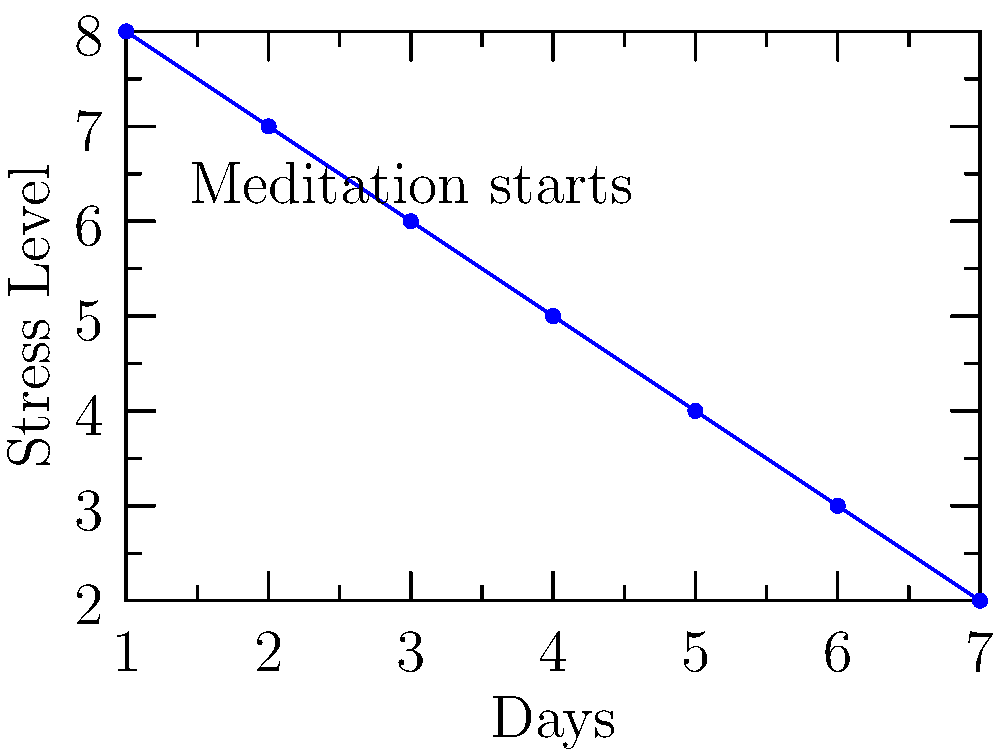The line graph shows the Nobel laureate's stress levels over a week. On which day did their stress level decrease most significantly, and what technique might you have suggested to achieve this reduction? To answer this question, we need to analyze the graph step-by-step:

1. The y-axis represents stress levels, while the x-axis shows the days of the week.
2. We need to look for the steepest decline in the line, which indicates the most significant decrease in stress.
3. The steepest decline occurs between day 2 and day 3.
4. The graph is labeled "Meditation starts" at day 2, suggesting that meditation was introduced as a stress management technique.
5. As a supportive partner, you likely suggested meditation to help manage the Nobel laureate's stress levels.
6. The significant drop in stress levels from day 2 to day 3 coincides with the start of meditation practice.

Therefore, the most significant decrease in stress level occurred on day 3, and the technique suggested was likely meditation.
Answer: Day 3; meditation 